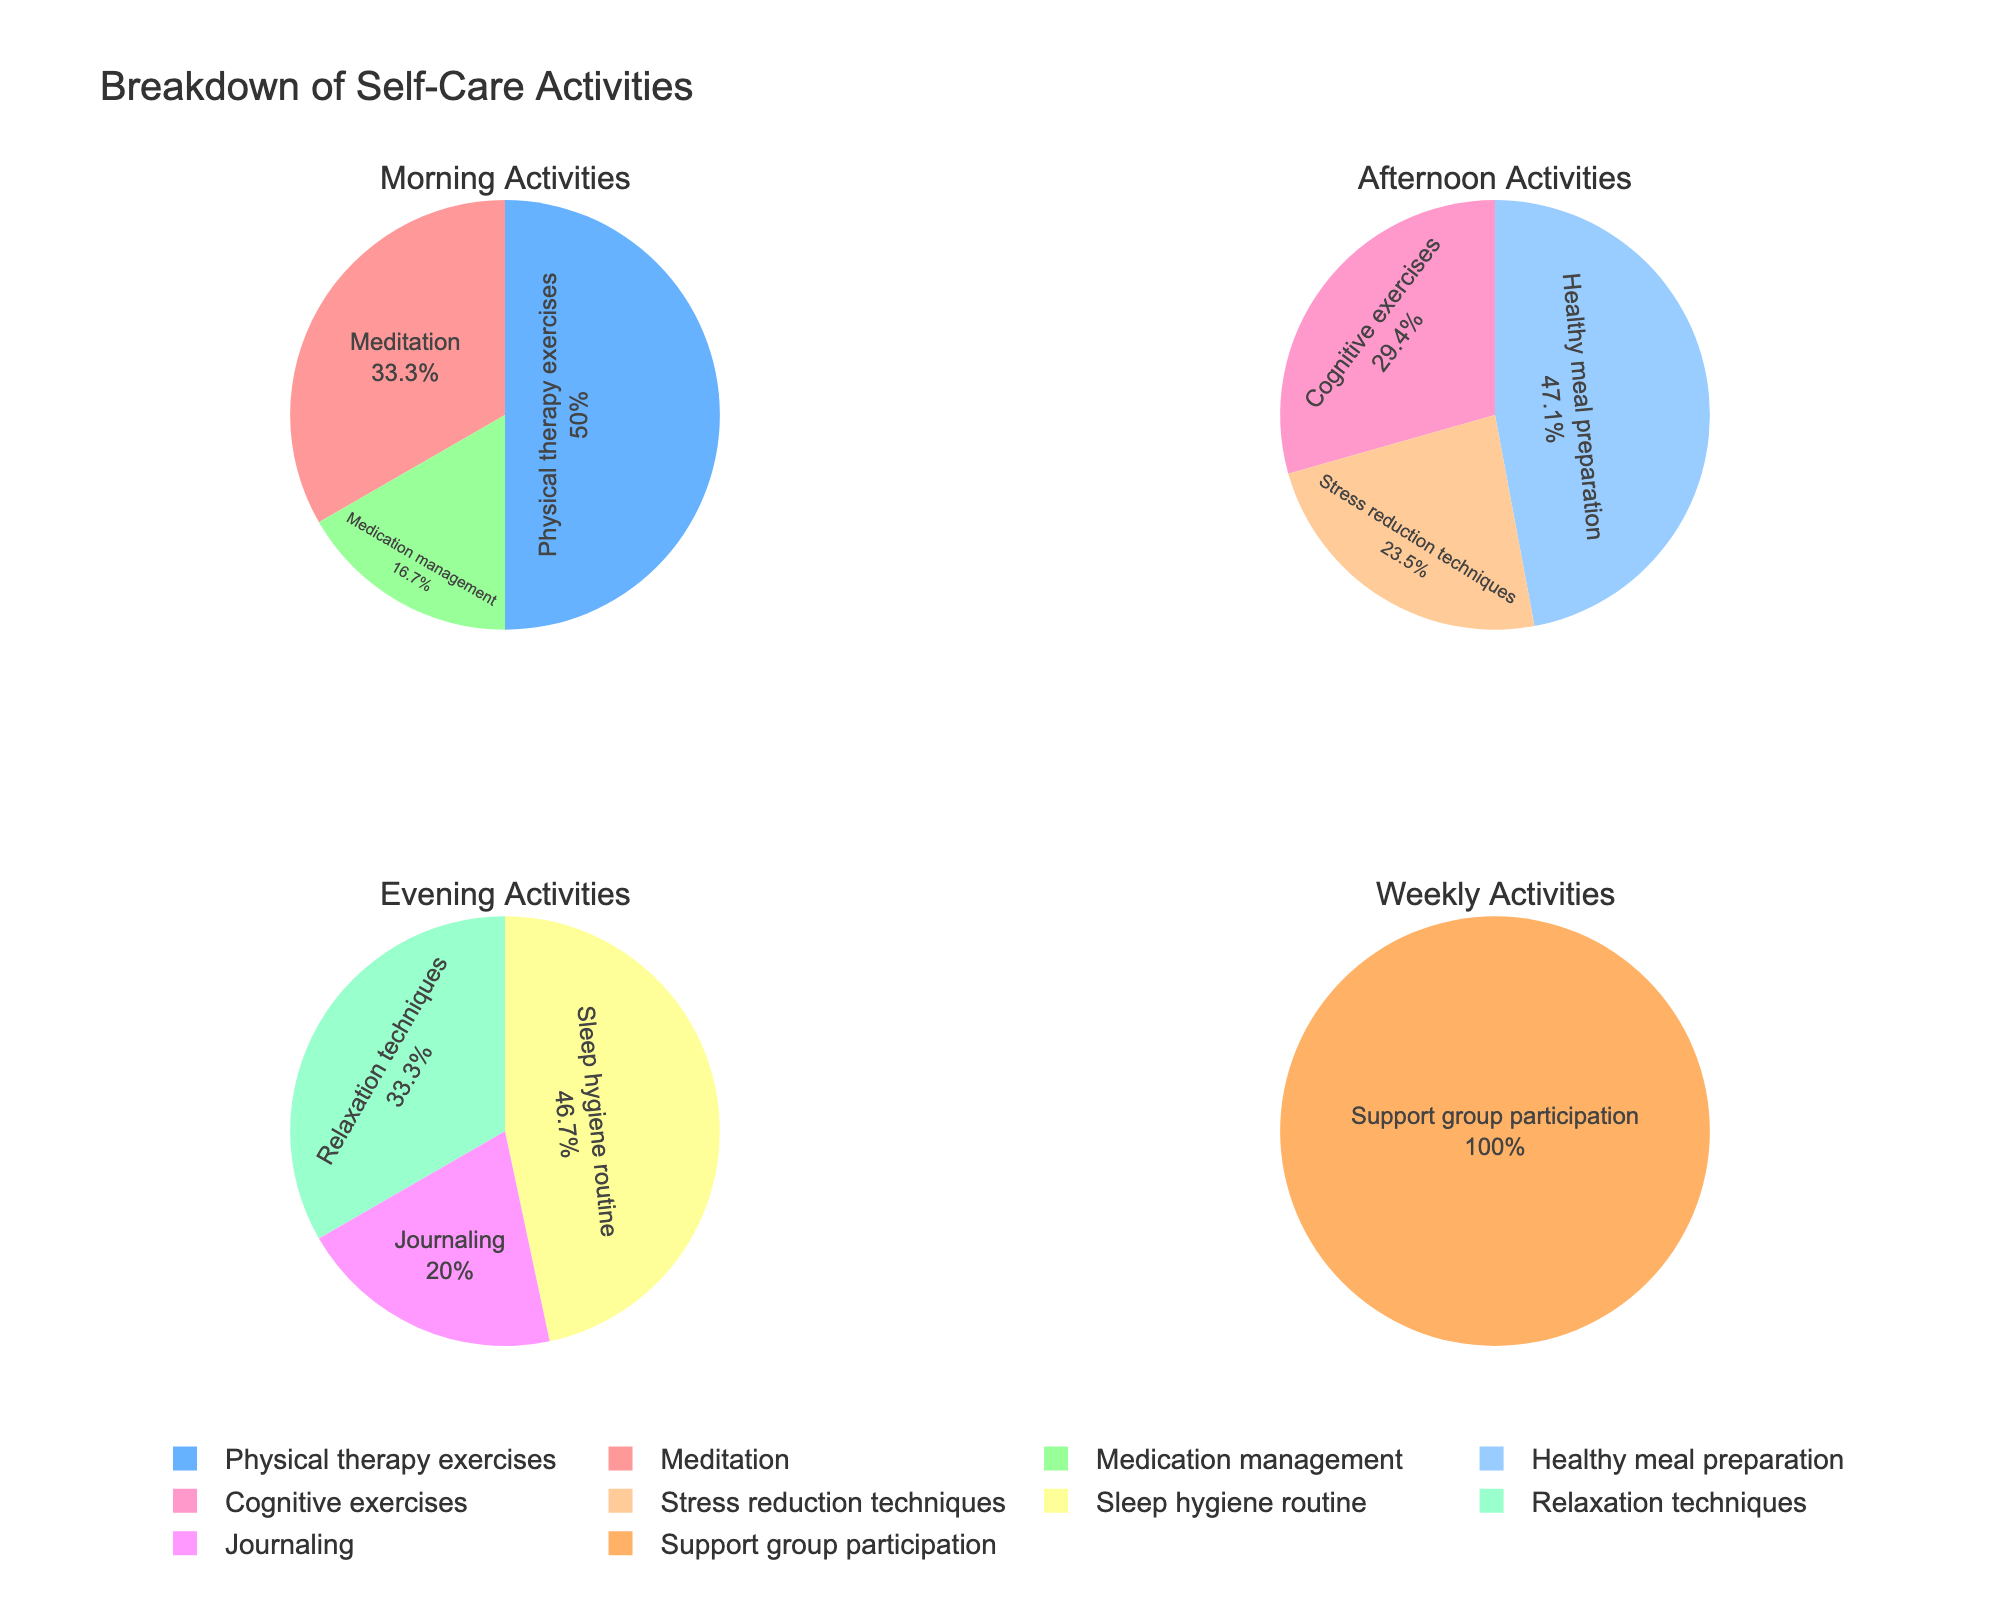What activities are included in the morning section? The morning section includes "Meditation", "Physical therapy exercises", and "Medication management". These activities are grouped together in the top-left pie chart.
Answer: Meditation, Physical therapy exercises, Medication management Which section has the highest total time spent on activities? The total time spent on each section can be calculated by summing the time for all activities in that section. Morning: 30+45+15=90, Afternoon: 20+25+40=85, Evening: 35+15+25=75, Weekly: 60. The morning section has the highest total time spent, with 90 minutes.
Answer: Morning section What is the percentage of time spent on "Support group participation" relative to the Weekly section? "Support group participation" is the only activity in the Weekly section, so it takes up 100% of the time in that section.
Answer: 100% Comparing "Healthy meal preparation" and "Sleep hygiene routine", which takes more time? "Healthy meal preparation" takes 40 minutes, while "Sleep hygiene routine" takes 35 minutes. Therefore, "Healthy meal preparation" takes more time.
Answer: Healthy meal preparation How is the time distribution for the Evening activities? Evening activities include "Sleep hygiene routine" (35 minutes), "Journaling" (15 minutes), and "Relaxation techniques" (25 minutes). The time distribution can be observed from the pie chart's segments in the bottom-left section.
Answer: Sleep hygiene routine 35, Journaling 15, Relaxation techniques 25 What is the main focus of afternoon activities? The afternoon section includes "Stress reduction techniques", "Cognitive exercises", and "Healthy meal preparation". The activity with the most significant focus, in terms of time spent, is "Healthy meal preparation" (40 minutes).
Answer: Healthy meal preparation Which activity in the morning section has the least time spent? Among the morning activities, "Medication management" has the least time spent, with 15 minutes.
Answer: Medication management How much more time is spent on "Physical therapy exercises" compared to "Journaling"? "Physical therapy exercises" takes 45 minutes, and "Journaling" takes 15 minutes. The difference is 45 - 15 = 30 minutes.
Answer: 30 minutes What proportion of time is allocated to "Meditation" and "Stress reduction techniques" when combined? Combined, "Meditation" (30 minutes) and "Stress reduction techniques" (20 minutes) take 30 + 20 = 50 minutes. The overall total time is 310 minutes. So, the proportion is 50/310.
Answer: Approximately 16.13% In the Evening section, what is the ratio of time spent on "Sleep hygiene routine" to "Relaxation techniques"? "Sleep hygiene routine" takes 35 minutes and "Relaxation techniques" take 25 minutes. The ratio of time spent is 35:25 or simplified to 7:5.
Answer: 7:5 